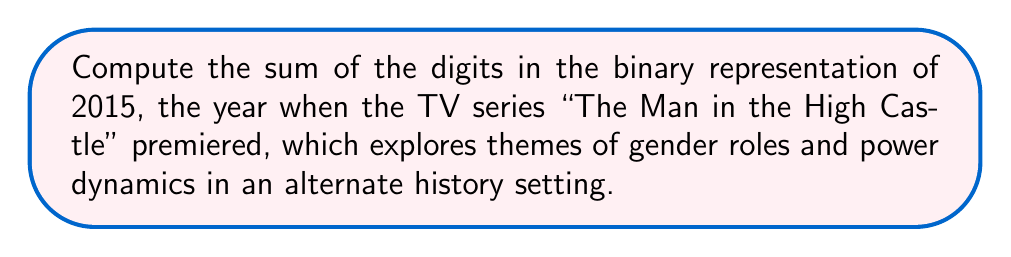Solve this math problem. Let's approach this step-by-step:

1) First, we need to convert 2015 to binary. We can do this by repeatedly dividing by 2 and keeping track of the remainders:

   $2015 \div 2 = 1007$ remainder $1$
   $1007 \div 2 = 503$  remainder $1$
   $503 \div 2 = 251$   remainder $1$
   $251 \div 2 = 125$   remainder $1$
   $125 \div 2 = 62$    remainder $1$
   $62 \div 2 = 31$     remainder $0$
   $31 \div 2 = 15$     remainder $1$
   $15 \div 2 = 7$      remainder $1$
   $7 \div 2 = 3$       remainder $1$
   $3 \div 2 = 1$       remainder $1$
   $1 \div 2 = 0$       remainder $1$

2) Reading the remainders from bottom to top, we get:
   
   $2015_{10} = 11111011111_2$

3) Now, we need to sum the digits in this binary representation:

   $1 + 1 + 1 + 1 + 1 + 0 + 1 + 1 + 1 + 1 + 1 = 10$

Therefore, the sum of the digits in the binary representation of 2015 is 10.
Answer: 10 